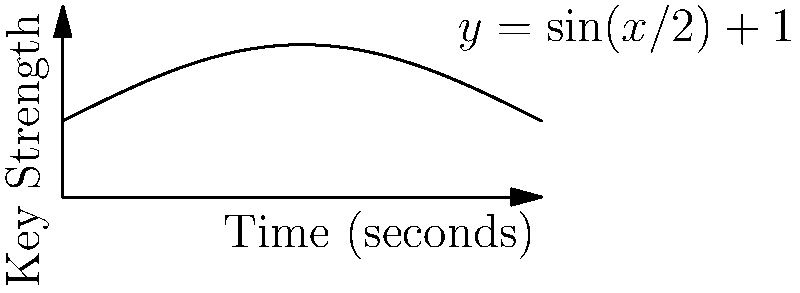In a cryptographic system, the strength of generated keys follows a periodic function described by $y = \sin(x/2) + 1$, where $x$ represents time in seconds and $y$ represents key strength. What is the period of this function, and at what time intervals does the key strength reach its maximum value? To solve this problem, we need to follow these steps:

1) First, let's determine the period of the function. The general form of a sine function is $\sin(bx)$, where the period is given by $\frac{2\pi}{|b|}$.

2) In our case, the function is $\sin(x/2)$, so $b = 1/2$.

3) Therefore, the period is:
   $\frac{2\pi}{|1/2|} = 2\pi \cdot 2 = 4\pi$ seconds

4) Now, to find when the key strength reaches its maximum, we need to determine when $\sin(x/2)$ reaches its maximum value of 1.

5) This occurs when $x/2 = \pi/2 + 2\pi n$, where $n$ is any integer.

6) Solving for $x$:
   $x = \pi + 4\pi n$ seconds

7) This means the maximum occurs at $\pi, 5\pi, 9\pi, ...$ seconds, or every $4\pi$ seconds, which matches our calculated period.
Answer: Period: $4\pi$ seconds; Maximum at: $\pi + 4\pi n$ seconds, where $n$ is any integer. 